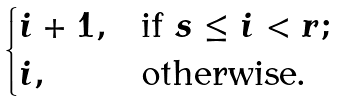Convert formula to latex. <formula><loc_0><loc_0><loc_500><loc_500>\begin{cases} i + 1 , & \text {if } s \leq i < r ; \\ i , & \text {otherwise.} \end{cases}</formula> 